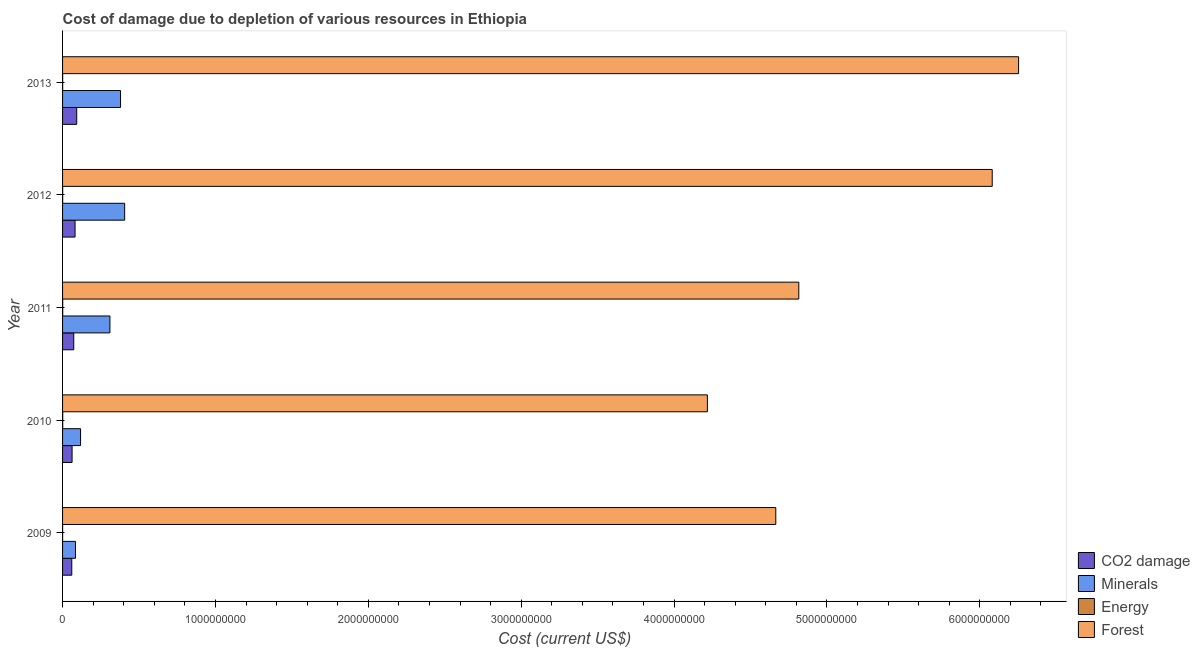Are the number of bars per tick equal to the number of legend labels?
Ensure brevity in your answer.  Yes. How many bars are there on the 1st tick from the top?
Your answer should be very brief. 4. How many bars are there on the 3rd tick from the bottom?
Offer a very short reply. 4. What is the label of the 4th group of bars from the top?
Ensure brevity in your answer.  2010. What is the cost of damage due to depletion of minerals in 2011?
Ensure brevity in your answer.  3.10e+08. Across all years, what is the maximum cost of damage due to depletion of coal?
Make the answer very short. 9.26e+07. Across all years, what is the minimum cost of damage due to depletion of coal?
Offer a very short reply. 6.03e+07. In which year was the cost of damage due to depletion of forests minimum?
Give a very brief answer. 2010. What is the total cost of damage due to depletion of coal in the graph?
Make the answer very short. 3.70e+08. What is the difference between the cost of damage due to depletion of forests in 2011 and that in 2012?
Give a very brief answer. -1.27e+09. What is the difference between the cost of damage due to depletion of coal in 2010 and the cost of damage due to depletion of minerals in 2009?
Keep it short and to the point. -2.23e+07. What is the average cost of damage due to depletion of forests per year?
Provide a short and direct response. 5.21e+09. In the year 2012, what is the difference between the cost of damage due to depletion of energy and cost of damage due to depletion of minerals?
Provide a succinct answer. -4.06e+08. What is the ratio of the cost of damage due to depletion of minerals in 2010 to that in 2011?
Provide a short and direct response. 0.38. What is the difference between the highest and the second highest cost of damage due to depletion of forests?
Provide a succinct answer. 1.73e+08. What is the difference between the highest and the lowest cost of damage due to depletion of minerals?
Ensure brevity in your answer.  3.22e+08. Is it the case that in every year, the sum of the cost of damage due to depletion of forests and cost of damage due to depletion of coal is greater than the sum of cost of damage due to depletion of minerals and cost of damage due to depletion of energy?
Make the answer very short. No. What does the 1st bar from the top in 2009 represents?
Provide a short and direct response. Forest. What does the 4th bar from the bottom in 2012 represents?
Your answer should be very brief. Forest. Are all the bars in the graph horizontal?
Make the answer very short. Yes. What is the difference between two consecutive major ticks on the X-axis?
Provide a succinct answer. 1.00e+09. Does the graph contain grids?
Your answer should be very brief. No. Where does the legend appear in the graph?
Ensure brevity in your answer.  Bottom right. How many legend labels are there?
Your answer should be very brief. 4. How are the legend labels stacked?
Keep it short and to the point. Vertical. What is the title of the graph?
Keep it short and to the point. Cost of damage due to depletion of various resources in Ethiopia . What is the label or title of the X-axis?
Provide a short and direct response. Cost (current US$). What is the label or title of the Y-axis?
Give a very brief answer. Year. What is the Cost (current US$) of CO2 damage in 2009?
Offer a terse response. 6.03e+07. What is the Cost (current US$) in Minerals in 2009?
Provide a short and direct response. 8.45e+07. What is the Cost (current US$) in Energy in 2009?
Offer a very short reply. 2.68e+05. What is the Cost (current US$) in Forest in 2009?
Make the answer very short. 4.67e+09. What is the Cost (current US$) in CO2 damage in 2010?
Offer a very short reply. 6.22e+07. What is the Cost (current US$) in Minerals in 2010?
Your answer should be compact. 1.18e+08. What is the Cost (current US$) of Energy in 2010?
Your answer should be compact. 1.04e+06. What is the Cost (current US$) in Forest in 2010?
Your answer should be very brief. 4.22e+09. What is the Cost (current US$) of CO2 damage in 2011?
Ensure brevity in your answer.  7.31e+07. What is the Cost (current US$) of Minerals in 2011?
Give a very brief answer. 3.10e+08. What is the Cost (current US$) in Energy in 2011?
Provide a short and direct response. 9.09e+05. What is the Cost (current US$) in Forest in 2011?
Your answer should be compact. 4.82e+09. What is the Cost (current US$) of CO2 damage in 2012?
Keep it short and to the point. 8.17e+07. What is the Cost (current US$) in Minerals in 2012?
Make the answer very short. 4.06e+08. What is the Cost (current US$) of Energy in 2012?
Keep it short and to the point. 6.99e+05. What is the Cost (current US$) in Forest in 2012?
Make the answer very short. 6.08e+09. What is the Cost (current US$) in CO2 damage in 2013?
Offer a terse response. 9.26e+07. What is the Cost (current US$) of Minerals in 2013?
Your response must be concise. 3.79e+08. What is the Cost (current US$) of Energy in 2013?
Ensure brevity in your answer.  6.23e+05. What is the Cost (current US$) in Forest in 2013?
Keep it short and to the point. 6.25e+09. Across all years, what is the maximum Cost (current US$) in CO2 damage?
Your answer should be very brief. 9.26e+07. Across all years, what is the maximum Cost (current US$) of Minerals?
Ensure brevity in your answer.  4.06e+08. Across all years, what is the maximum Cost (current US$) of Energy?
Your answer should be very brief. 1.04e+06. Across all years, what is the maximum Cost (current US$) of Forest?
Keep it short and to the point. 6.25e+09. Across all years, what is the minimum Cost (current US$) in CO2 damage?
Offer a terse response. 6.03e+07. Across all years, what is the minimum Cost (current US$) in Minerals?
Give a very brief answer. 8.45e+07. Across all years, what is the minimum Cost (current US$) in Energy?
Ensure brevity in your answer.  2.68e+05. Across all years, what is the minimum Cost (current US$) in Forest?
Your response must be concise. 4.22e+09. What is the total Cost (current US$) of CO2 damage in the graph?
Offer a terse response. 3.70e+08. What is the total Cost (current US$) of Minerals in the graph?
Give a very brief answer. 1.30e+09. What is the total Cost (current US$) of Energy in the graph?
Make the answer very short. 3.54e+06. What is the total Cost (current US$) of Forest in the graph?
Ensure brevity in your answer.  2.60e+1. What is the difference between the Cost (current US$) of CO2 damage in 2009 and that in 2010?
Provide a succinct answer. -1.93e+06. What is the difference between the Cost (current US$) in Minerals in 2009 and that in 2010?
Make the answer very short. -3.32e+07. What is the difference between the Cost (current US$) in Energy in 2009 and that in 2010?
Offer a terse response. -7.77e+05. What is the difference between the Cost (current US$) of Forest in 2009 and that in 2010?
Offer a very short reply. 4.47e+08. What is the difference between the Cost (current US$) in CO2 damage in 2009 and that in 2011?
Your answer should be very brief. -1.28e+07. What is the difference between the Cost (current US$) of Minerals in 2009 and that in 2011?
Give a very brief answer. -2.25e+08. What is the difference between the Cost (current US$) in Energy in 2009 and that in 2011?
Keep it short and to the point. -6.41e+05. What is the difference between the Cost (current US$) in Forest in 2009 and that in 2011?
Your answer should be compact. -1.51e+08. What is the difference between the Cost (current US$) of CO2 damage in 2009 and that in 2012?
Provide a short and direct response. -2.14e+07. What is the difference between the Cost (current US$) in Minerals in 2009 and that in 2012?
Ensure brevity in your answer.  -3.22e+08. What is the difference between the Cost (current US$) in Energy in 2009 and that in 2012?
Provide a short and direct response. -4.31e+05. What is the difference between the Cost (current US$) of Forest in 2009 and that in 2012?
Offer a terse response. -1.42e+09. What is the difference between the Cost (current US$) of CO2 damage in 2009 and that in 2013?
Provide a succinct answer. -3.23e+07. What is the difference between the Cost (current US$) of Minerals in 2009 and that in 2013?
Provide a succinct answer. -2.95e+08. What is the difference between the Cost (current US$) of Energy in 2009 and that in 2013?
Provide a succinct answer. -3.56e+05. What is the difference between the Cost (current US$) in Forest in 2009 and that in 2013?
Your answer should be very brief. -1.59e+09. What is the difference between the Cost (current US$) in CO2 damage in 2010 and that in 2011?
Give a very brief answer. -1.09e+07. What is the difference between the Cost (current US$) in Minerals in 2010 and that in 2011?
Your answer should be compact. -1.92e+08. What is the difference between the Cost (current US$) in Energy in 2010 and that in 2011?
Provide a short and direct response. 1.36e+05. What is the difference between the Cost (current US$) in Forest in 2010 and that in 2011?
Your answer should be very brief. -5.98e+08. What is the difference between the Cost (current US$) in CO2 damage in 2010 and that in 2012?
Provide a succinct answer. -1.95e+07. What is the difference between the Cost (current US$) of Minerals in 2010 and that in 2012?
Provide a succinct answer. -2.88e+08. What is the difference between the Cost (current US$) in Energy in 2010 and that in 2012?
Make the answer very short. 3.46e+05. What is the difference between the Cost (current US$) in Forest in 2010 and that in 2012?
Provide a short and direct response. -1.86e+09. What is the difference between the Cost (current US$) in CO2 damage in 2010 and that in 2013?
Offer a very short reply. -3.04e+07. What is the difference between the Cost (current US$) in Minerals in 2010 and that in 2013?
Provide a short and direct response. -2.61e+08. What is the difference between the Cost (current US$) in Energy in 2010 and that in 2013?
Keep it short and to the point. 4.21e+05. What is the difference between the Cost (current US$) of Forest in 2010 and that in 2013?
Provide a short and direct response. -2.04e+09. What is the difference between the Cost (current US$) in CO2 damage in 2011 and that in 2012?
Give a very brief answer. -8.60e+06. What is the difference between the Cost (current US$) of Minerals in 2011 and that in 2012?
Your answer should be very brief. -9.64e+07. What is the difference between the Cost (current US$) in Energy in 2011 and that in 2012?
Provide a succinct answer. 2.10e+05. What is the difference between the Cost (current US$) in Forest in 2011 and that in 2012?
Offer a very short reply. -1.27e+09. What is the difference between the Cost (current US$) of CO2 damage in 2011 and that in 2013?
Make the answer very short. -1.95e+07. What is the difference between the Cost (current US$) in Minerals in 2011 and that in 2013?
Offer a terse response. -6.94e+07. What is the difference between the Cost (current US$) in Energy in 2011 and that in 2013?
Make the answer very short. 2.85e+05. What is the difference between the Cost (current US$) of Forest in 2011 and that in 2013?
Ensure brevity in your answer.  -1.44e+09. What is the difference between the Cost (current US$) in CO2 damage in 2012 and that in 2013?
Offer a terse response. -1.09e+07. What is the difference between the Cost (current US$) of Minerals in 2012 and that in 2013?
Provide a succinct answer. 2.70e+07. What is the difference between the Cost (current US$) of Energy in 2012 and that in 2013?
Make the answer very short. 7.53e+04. What is the difference between the Cost (current US$) of Forest in 2012 and that in 2013?
Make the answer very short. -1.73e+08. What is the difference between the Cost (current US$) in CO2 damage in 2009 and the Cost (current US$) in Minerals in 2010?
Offer a very short reply. -5.75e+07. What is the difference between the Cost (current US$) of CO2 damage in 2009 and the Cost (current US$) of Energy in 2010?
Offer a very short reply. 5.92e+07. What is the difference between the Cost (current US$) of CO2 damage in 2009 and the Cost (current US$) of Forest in 2010?
Provide a succinct answer. -4.16e+09. What is the difference between the Cost (current US$) in Minerals in 2009 and the Cost (current US$) in Energy in 2010?
Offer a terse response. 8.35e+07. What is the difference between the Cost (current US$) of Minerals in 2009 and the Cost (current US$) of Forest in 2010?
Ensure brevity in your answer.  -4.13e+09. What is the difference between the Cost (current US$) of Energy in 2009 and the Cost (current US$) of Forest in 2010?
Keep it short and to the point. -4.22e+09. What is the difference between the Cost (current US$) of CO2 damage in 2009 and the Cost (current US$) of Minerals in 2011?
Ensure brevity in your answer.  -2.50e+08. What is the difference between the Cost (current US$) in CO2 damage in 2009 and the Cost (current US$) in Energy in 2011?
Provide a short and direct response. 5.94e+07. What is the difference between the Cost (current US$) in CO2 damage in 2009 and the Cost (current US$) in Forest in 2011?
Your answer should be compact. -4.76e+09. What is the difference between the Cost (current US$) in Minerals in 2009 and the Cost (current US$) in Energy in 2011?
Ensure brevity in your answer.  8.36e+07. What is the difference between the Cost (current US$) of Minerals in 2009 and the Cost (current US$) of Forest in 2011?
Your response must be concise. -4.73e+09. What is the difference between the Cost (current US$) of Energy in 2009 and the Cost (current US$) of Forest in 2011?
Your response must be concise. -4.82e+09. What is the difference between the Cost (current US$) in CO2 damage in 2009 and the Cost (current US$) in Minerals in 2012?
Your answer should be very brief. -3.46e+08. What is the difference between the Cost (current US$) in CO2 damage in 2009 and the Cost (current US$) in Energy in 2012?
Offer a very short reply. 5.96e+07. What is the difference between the Cost (current US$) in CO2 damage in 2009 and the Cost (current US$) in Forest in 2012?
Your answer should be compact. -6.02e+09. What is the difference between the Cost (current US$) in Minerals in 2009 and the Cost (current US$) in Energy in 2012?
Provide a short and direct response. 8.38e+07. What is the difference between the Cost (current US$) in Minerals in 2009 and the Cost (current US$) in Forest in 2012?
Provide a short and direct response. -6.00e+09. What is the difference between the Cost (current US$) of Energy in 2009 and the Cost (current US$) of Forest in 2012?
Offer a very short reply. -6.08e+09. What is the difference between the Cost (current US$) of CO2 damage in 2009 and the Cost (current US$) of Minerals in 2013?
Offer a very short reply. -3.19e+08. What is the difference between the Cost (current US$) in CO2 damage in 2009 and the Cost (current US$) in Energy in 2013?
Provide a succinct answer. 5.97e+07. What is the difference between the Cost (current US$) in CO2 damage in 2009 and the Cost (current US$) in Forest in 2013?
Provide a short and direct response. -6.19e+09. What is the difference between the Cost (current US$) in Minerals in 2009 and the Cost (current US$) in Energy in 2013?
Provide a succinct answer. 8.39e+07. What is the difference between the Cost (current US$) in Minerals in 2009 and the Cost (current US$) in Forest in 2013?
Give a very brief answer. -6.17e+09. What is the difference between the Cost (current US$) in Energy in 2009 and the Cost (current US$) in Forest in 2013?
Your response must be concise. -6.25e+09. What is the difference between the Cost (current US$) in CO2 damage in 2010 and the Cost (current US$) in Minerals in 2011?
Your response must be concise. -2.48e+08. What is the difference between the Cost (current US$) of CO2 damage in 2010 and the Cost (current US$) of Energy in 2011?
Provide a succinct answer. 6.13e+07. What is the difference between the Cost (current US$) of CO2 damage in 2010 and the Cost (current US$) of Forest in 2011?
Your answer should be very brief. -4.75e+09. What is the difference between the Cost (current US$) of Minerals in 2010 and the Cost (current US$) of Energy in 2011?
Your answer should be very brief. 1.17e+08. What is the difference between the Cost (current US$) in Minerals in 2010 and the Cost (current US$) in Forest in 2011?
Your response must be concise. -4.70e+09. What is the difference between the Cost (current US$) in Energy in 2010 and the Cost (current US$) in Forest in 2011?
Your answer should be compact. -4.82e+09. What is the difference between the Cost (current US$) in CO2 damage in 2010 and the Cost (current US$) in Minerals in 2012?
Your response must be concise. -3.44e+08. What is the difference between the Cost (current US$) in CO2 damage in 2010 and the Cost (current US$) in Energy in 2012?
Your answer should be compact. 6.15e+07. What is the difference between the Cost (current US$) in CO2 damage in 2010 and the Cost (current US$) in Forest in 2012?
Offer a terse response. -6.02e+09. What is the difference between the Cost (current US$) in Minerals in 2010 and the Cost (current US$) in Energy in 2012?
Offer a very short reply. 1.17e+08. What is the difference between the Cost (current US$) of Minerals in 2010 and the Cost (current US$) of Forest in 2012?
Offer a terse response. -5.96e+09. What is the difference between the Cost (current US$) of Energy in 2010 and the Cost (current US$) of Forest in 2012?
Give a very brief answer. -6.08e+09. What is the difference between the Cost (current US$) in CO2 damage in 2010 and the Cost (current US$) in Minerals in 2013?
Give a very brief answer. -3.17e+08. What is the difference between the Cost (current US$) in CO2 damage in 2010 and the Cost (current US$) in Energy in 2013?
Provide a short and direct response. 6.16e+07. What is the difference between the Cost (current US$) in CO2 damage in 2010 and the Cost (current US$) in Forest in 2013?
Provide a succinct answer. -6.19e+09. What is the difference between the Cost (current US$) in Minerals in 2010 and the Cost (current US$) in Energy in 2013?
Your response must be concise. 1.17e+08. What is the difference between the Cost (current US$) of Minerals in 2010 and the Cost (current US$) of Forest in 2013?
Offer a terse response. -6.14e+09. What is the difference between the Cost (current US$) of Energy in 2010 and the Cost (current US$) of Forest in 2013?
Provide a short and direct response. -6.25e+09. What is the difference between the Cost (current US$) in CO2 damage in 2011 and the Cost (current US$) in Minerals in 2012?
Your answer should be compact. -3.33e+08. What is the difference between the Cost (current US$) in CO2 damage in 2011 and the Cost (current US$) in Energy in 2012?
Keep it short and to the point. 7.24e+07. What is the difference between the Cost (current US$) in CO2 damage in 2011 and the Cost (current US$) in Forest in 2012?
Offer a terse response. -6.01e+09. What is the difference between the Cost (current US$) in Minerals in 2011 and the Cost (current US$) in Energy in 2012?
Keep it short and to the point. 3.09e+08. What is the difference between the Cost (current US$) of Minerals in 2011 and the Cost (current US$) of Forest in 2012?
Your response must be concise. -5.77e+09. What is the difference between the Cost (current US$) in Energy in 2011 and the Cost (current US$) in Forest in 2012?
Make the answer very short. -6.08e+09. What is the difference between the Cost (current US$) of CO2 damage in 2011 and the Cost (current US$) of Minerals in 2013?
Your answer should be compact. -3.06e+08. What is the difference between the Cost (current US$) in CO2 damage in 2011 and the Cost (current US$) in Energy in 2013?
Offer a very short reply. 7.25e+07. What is the difference between the Cost (current US$) of CO2 damage in 2011 and the Cost (current US$) of Forest in 2013?
Provide a succinct answer. -6.18e+09. What is the difference between the Cost (current US$) of Minerals in 2011 and the Cost (current US$) of Energy in 2013?
Give a very brief answer. 3.09e+08. What is the difference between the Cost (current US$) of Minerals in 2011 and the Cost (current US$) of Forest in 2013?
Ensure brevity in your answer.  -5.94e+09. What is the difference between the Cost (current US$) of Energy in 2011 and the Cost (current US$) of Forest in 2013?
Your response must be concise. -6.25e+09. What is the difference between the Cost (current US$) of CO2 damage in 2012 and the Cost (current US$) of Minerals in 2013?
Offer a terse response. -2.98e+08. What is the difference between the Cost (current US$) of CO2 damage in 2012 and the Cost (current US$) of Energy in 2013?
Your response must be concise. 8.11e+07. What is the difference between the Cost (current US$) in CO2 damage in 2012 and the Cost (current US$) in Forest in 2013?
Offer a very short reply. -6.17e+09. What is the difference between the Cost (current US$) of Minerals in 2012 and the Cost (current US$) of Energy in 2013?
Offer a terse response. 4.06e+08. What is the difference between the Cost (current US$) of Minerals in 2012 and the Cost (current US$) of Forest in 2013?
Make the answer very short. -5.85e+09. What is the difference between the Cost (current US$) in Energy in 2012 and the Cost (current US$) in Forest in 2013?
Your answer should be very brief. -6.25e+09. What is the average Cost (current US$) in CO2 damage per year?
Your answer should be very brief. 7.40e+07. What is the average Cost (current US$) in Minerals per year?
Give a very brief answer. 2.60e+08. What is the average Cost (current US$) of Energy per year?
Offer a very short reply. 7.09e+05. What is the average Cost (current US$) of Forest per year?
Provide a succinct answer. 5.21e+09. In the year 2009, what is the difference between the Cost (current US$) of CO2 damage and Cost (current US$) of Minerals?
Your answer should be very brief. -2.43e+07. In the year 2009, what is the difference between the Cost (current US$) in CO2 damage and Cost (current US$) in Energy?
Your answer should be compact. 6.00e+07. In the year 2009, what is the difference between the Cost (current US$) in CO2 damage and Cost (current US$) in Forest?
Your response must be concise. -4.61e+09. In the year 2009, what is the difference between the Cost (current US$) of Minerals and Cost (current US$) of Energy?
Offer a very short reply. 8.43e+07. In the year 2009, what is the difference between the Cost (current US$) of Minerals and Cost (current US$) of Forest?
Your answer should be very brief. -4.58e+09. In the year 2009, what is the difference between the Cost (current US$) of Energy and Cost (current US$) of Forest?
Provide a short and direct response. -4.67e+09. In the year 2010, what is the difference between the Cost (current US$) in CO2 damage and Cost (current US$) in Minerals?
Keep it short and to the point. -5.56e+07. In the year 2010, what is the difference between the Cost (current US$) of CO2 damage and Cost (current US$) of Energy?
Make the answer very short. 6.12e+07. In the year 2010, what is the difference between the Cost (current US$) in CO2 damage and Cost (current US$) in Forest?
Keep it short and to the point. -4.16e+09. In the year 2010, what is the difference between the Cost (current US$) of Minerals and Cost (current US$) of Energy?
Your response must be concise. 1.17e+08. In the year 2010, what is the difference between the Cost (current US$) of Minerals and Cost (current US$) of Forest?
Give a very brief answer. -4.10e+09. In the year 2010, what is the difference between the Cost (current US$) in Energy and Cost (current US$) in Forest?
Your response must be concise. -4.22e+09. In the year 2011, what is the difference between the Cost (current US$) in CO2 damage and Cost (current US$) in Minerals?
Make the answer very short. -2.37e+08. In the year 2011, what is the difference between the Cost (current US$) in CO2 damage and Cost (current US$) in Energy?
Keep it short and to the point. 7.22e+07. In the year 2011, what is the difference between the Cost (current US$) in CO2 damage and Cost (current US$) in Forest?
Provide a succinct answer. -4.74e+09. In the year 2011, what is the difference between the Cost (current US$) of Minerals and Cost (current US$) of Energy?
Make the answer very short. 3.09e+08. In the year 2011, what is the difference between the Cost (current US$) of Minerals and Cost (current US$) of Forest?
Your response must be concise. -4.51e+09. In the year 2011, what is the difference between the Cost (current US$) of Energy and Cost (current US$) of Forest?
Provide a short and direct response. -4.82e+09. In the year 2012, what is the difference between the Cost (current US$) in CO2 damage and Cost (current US$) in Minerals?
Your response must be concise. -3.24e+08. In the year 2012, what is the difference between the Cost (current US$) of CO2 damage and Cost (current US$) of Energy?
Your answer should be compact. 8.10e+07. In the year 2012, what is the difference between the Cost (current US$) in CO2 damage and Cost (current US$) in Forest?
Your answer should be very brief. -6.00e+09. In the year 2012, what is the difference between the Cost (current US$) in Minerals and Cost (current US$) in Energy?
Keep it short and to the point. 4.06e+08. In the year 2012, what is the difference between the Cost (current US$) in Minerals and Cost (current US$) in Forest?
Ensure brevity in your answer.  -5.68e+09. In the year 2012, what is the difference between the Cost (current US$) in Energy and Cost (current US$) in Forest?
Provide a succinct answer. -6.08e+09. In the year 2013, what is the difference between the Cost (current US$) in CO2 damage and Cost (current US$) in Minerals?
Your answer should be compact. -2.87e+08. In the year 2013, what is the difference between the Cost (current US$) in CO2 damage and Cost (current US$) in Energy?
Give a very brief answer. 9.20e+07. In the year 2013, what is the difference between the Cost (current US$) in CO2 damage and Cost (current US$) in Forest?
Offer a terse response. -6.16e+09. In the year 2013, what is the difference between the Cost (current US$) in Minerals and Cost (current US$) in Energy?
Make the answer very short. 3.79e+08. In the year 2013, what is the difference between the Cost (current US$) in Minerals and Cost (current US$) in Forest?
Keep it short and to the point. -5.87e+09. In the year 2013, what is the difference between the Cost (current US$) of Energy and Cost (current US$) of Forest?
Your response must be concise. -6.25e+09. What is the ratio of the Cost (current US$) of Minerals in 2009 to that in 2010?
Make the answer very short. 0.72. What is the ratio of the Cost (current US$) of Energy in 2009 to that in 2010?
Ensure brevity in your answer.  0.26. What is the ratio of the Cost (current US$) of Forest in 2009 to that in 2010?
Keep it short and to the point. 1.11. What is the ratio of the Cost (current US$) in CO2 damage in 2009 to that in 2011?
Offer a very short reply. 0.82. What is the ratio of the Cost (current US$) in Minerals in 2009 to that in 2011?
Your response must be concise. 0.27. What is the ratio of the Cost (current US$) of Energy in 2009 to that in 2011?
Give a very brief answer. 0.29. What is the ratio of the Cost (current US$) of Forest in 2009 to that in 2011?
Keep it short and to the point. 0.97. What is the ratio of the Cost (current US$) of CO2 damage in 2009 to that in 2012?
Offer a terse response. 0.74. What is the ratio of the Cost (current US$) of Minerals in 2009 to that in 2012?
Ensure brevity in your answer.  0.21. What is the ratio of the Cost (current US$) in Energy in 2009 to that in 2012?
Offer a very short reply. 0.38. What is the ratio of the Cost (current US$) of Forest in 2009 to that in 2012?
Offer a terse response. 0.77. What is the ratio of the Cost (current US$) in CO2 damage in 2009 to that in 2013?
Your answer should be very brief. 0.65. What is the ratio of the Cost (current US$) in Minerals in 2009 to that in 2013?
Your answer should be compact. 0.22. What is the ratio of the Cost (current US$) in Energy in 2009 to that in 2013?
Ensure brevity in your answer.  0.43. What is the ratio of the Cost (current US$) of Forest in 2009 to that in 2013?
Provide a short and direct response. 0.75. What is the ratio of the Cost (current US$) in CO2 damage in 2010 to that in 2011?
Provide a succinct answer. 0.85. What is the ratio of the Cost (current US$) in Minerals in 2010 to that in 2011?
Provide a short and direct response. 0.38. What is the ratio of the Cost (current US$) in Energy in 2010 to that in 2011?
Provide a succinct answer. 1.15. What is the ratio of the Cost (current US$) of Forest in 2010 to that in 2011?
Provide a succinct answer. 0.88. What is the ratio of the Cost (current US$) in CO2 damage in 2010 to that in 2012?
Your response must be concise. 0.76. What is the ratio of the Cost (current US$) in Minerals in 2010 to that in 2012?
Your answer should be compact. 0.29. What is the ratio of the Cost (current US$) in Energy in 2010 to that in 2012?
Provide a succinct answer. 1.5. What is the ratio of the Cost (current US$) in Forest in 2010 to that in 2012?
Make the answer very short. 0.69. What is the ratio of the Cost (current US$) of CO2 damage in 2010 to that in 2013?
Provide a short and direct response. 0.67. What is the ratio of the Cost (current US$) in Minerals in 2010 to that in 2013?
Make the answer very short. 0.31. What is the ratio of the Cost (current US$) of Energy in 2010 to that in 2013?
Give a very brief answer. 1.68. What is the ratio of the Cost (current US$) in Forest in 2010 to that in 2013?
Your answer should be very brief. 0.67. What is the ratio of the Cost (current US$) of CO2 damage in 2011 to that in 2012?
Your answer should be compact. 0.89. What is the ratio of the Cost (current US$) in Minerals in 2011 to that in 2012?
Provide a short and direct response. 0.76. What is the ratio of the Cost (current US$) of Energy in 2011 to that in 2012?
Give a very brief answer. 1.3. What is the ratio of the Cost (current US$) in Forest in 2011 to that in 2012?
Provide a succinct answer. 0.79. What is the ratio of the Cost (current US$) of CO2 damage in 2011 to that in 2013?
Provide a short and direct response. 0.79. What is the ratio of the Cost (current US$) in Minerals in 2011 to that in 2013?
Your answer should be very brief. 0.82. What is the ratio of the Cost (current US$) in Energy in 2011 to that in 2013?
Your answer should be very brief. 1.46. What is the ratio of the Cost (current US$) in Forest in 2011 to that in 2013?
Your answer should be compact. 0.77. What is the ratio of the Cost (current US$) of CO2 damage in 2012 to that in 2013?
Your response must be concise. 0.88. What is the ratio of the Cost (current US$) in Minerals in 2012 to that in 2013?
Make the answer very short. 1.07. What is the ratio of the Cost (current US$) of Energy in 2012 to that in 2013?
Your response must be concise. 1.12. What is the ratio of the Cost (current US$) in Forest in 2012 to that in 2013?
Provide a succinct answer. 0.97. What is the difference between the highest and the second highest Cost (current US$) in CO2 damage?
Your answer should be compact. 1.09e+07. What is the difference between the highest and the second highest Cost (current US$) of Minerals?
Ensure brevity in your answer.  2.70e+07. What is the difference between the highest and the second highest Cost (current US$) of Energy?
Give a very brief answer. 1.36e+05. What is the difference between the highest and the second highest Cost (current US$) in Forest?
Offer a very short reply. 1.73e+08. What is the difference between the highest and the lowest Cost (current US$) of CO2 damage?
Your answer should be very brief. 3.23e+07. What is the difference between the highest and the lowest Cost (current US$) of Minerals?
Offer a terse response. 3.22e+08. What is the difference between the highest and the lowest Cost (current US$) in Energy?
Provide a short and direct response. 7.77e+05. What is the difference between the highest and the lowest Cost (current US$) of Forest?
Your answer should be very brief. 2.04e+09. 